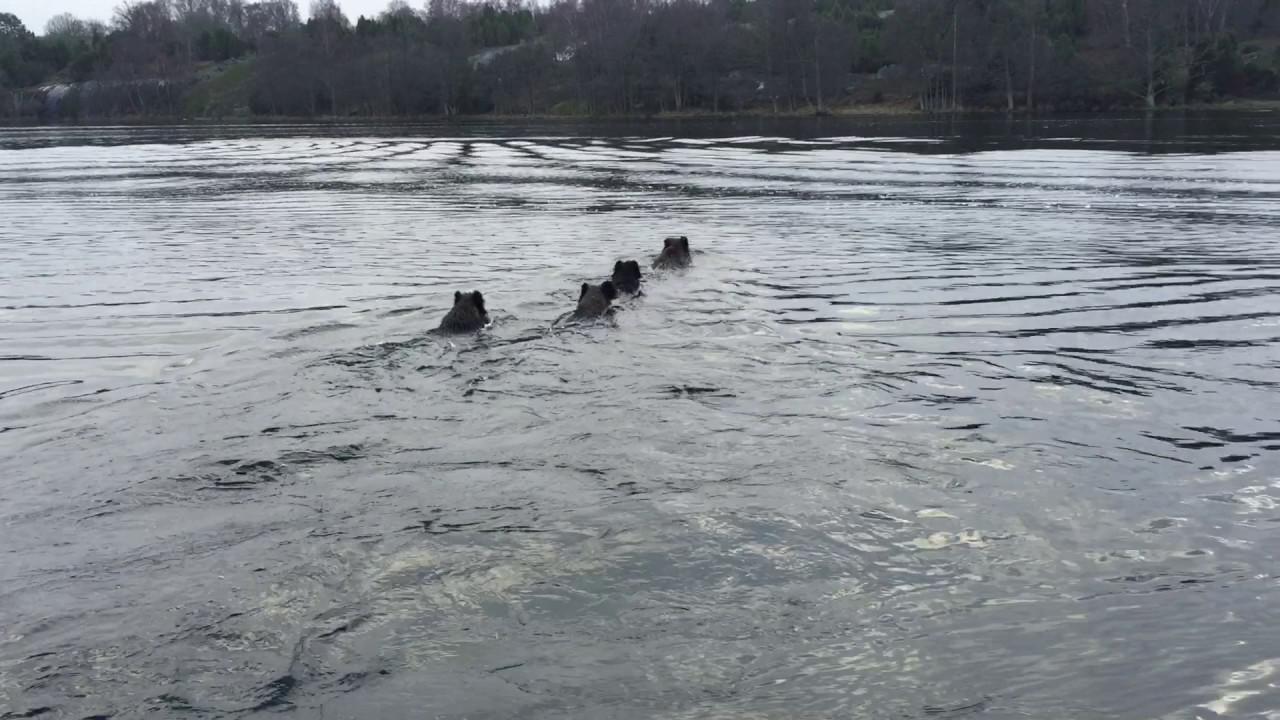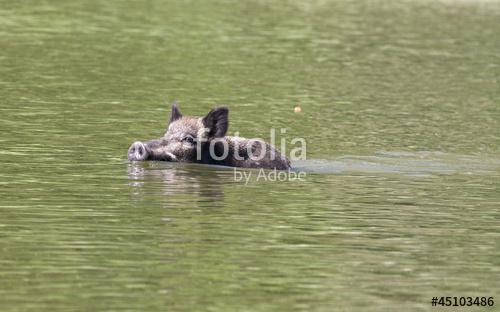The first image is the image on the left, the second image is the image on the right. Evaluate the accuracy of this statement regarding the images: "In the image on the left there is one boar swimming in the water.". Is it true? Answer yes or no. No. The first image is the image on the left, the second image is the image on the right. Examine the images to the left and right. Is the description "The left image contains one wild pig swimming leftward, with tall grass on the water's edge behind him." accurate? Answer yes or no. No. 